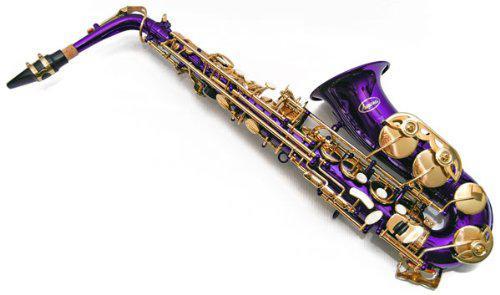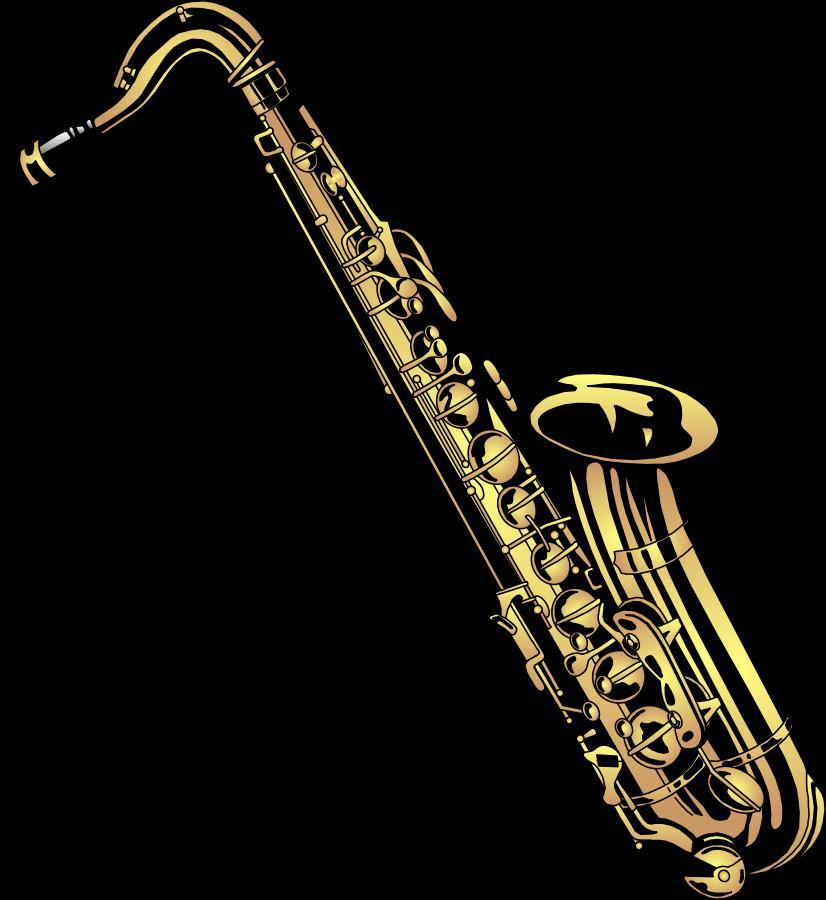The first image is the image on the left, the second image is the image on the right. Assess this claim about the two images: "The left image contains one purple and gold saxophone.". Correct or not? Answer yes or no. Yes. The first image is the image on the left, the second image is the image on the right. Examine the images to the left and right. Is the description "Each image shows a saxophone with an upturned bell, and one image features a violet-blue saxophone." accurate? Answer yes or no. Yes. 